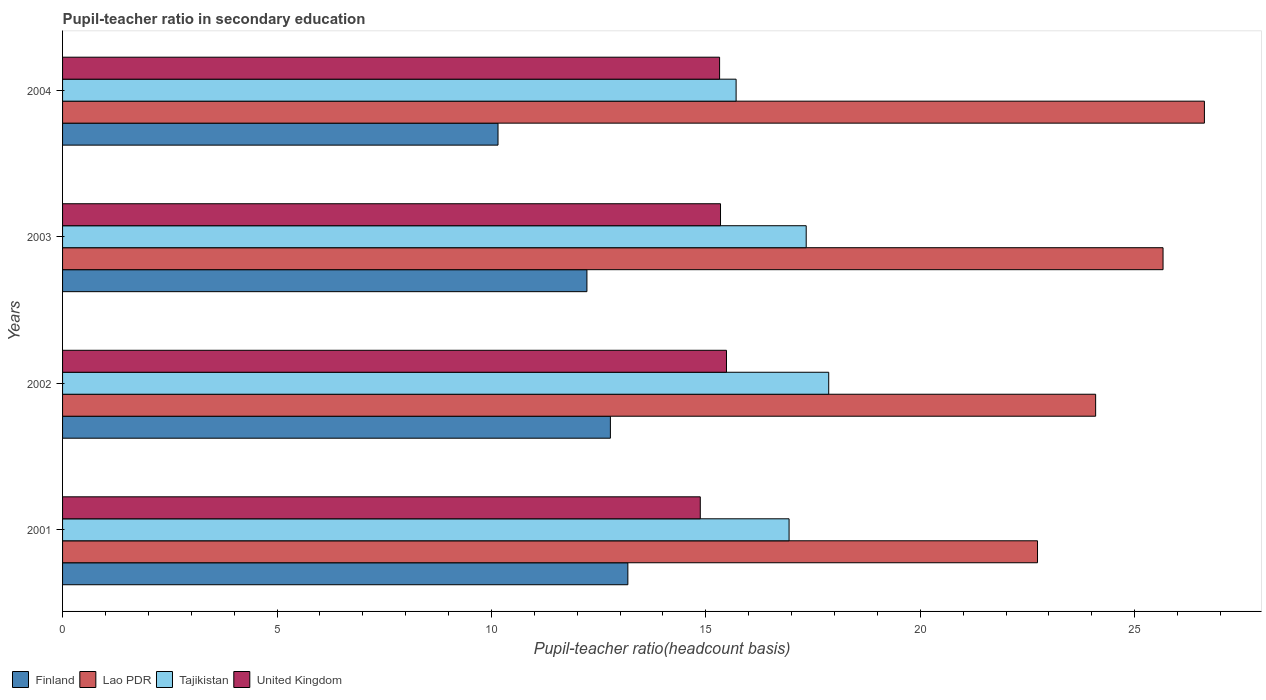Are the number of bars per tick equal to the number of legend labels?
Give a very brief answer. Yes. Are the number of bars on each tick of the Y-axis equal?
Your answer should be very brief. Yes. In how many cases, is the number of bars for a given year not equal to the number of legend labels?
Offer a terse response. 0. What is the pupil-teacher ratio in secondary education in Lao PDR in 2002?
Provide a short and direct response. 24.09. Across all years, what is the maximum pupil-teacher ratio in secondary education in Lao PDR?
Your response must be concise. 26.62. Across all years, what is the minimum pupil-teacher ratio in secondary education in Finland?
Offer a very short reply. 10.15. What is the total pupil-teacher ratio in secondary education in United Kingdom in the graph?
Ensure brevity in your answer.  61.01. What is the difference between the pupil-teacher ratio in secondary education in Tajikistan in 2001 and that in 2003?
Your response must be concise. -0.4. What is the difference between the pupil-teacher ratio in secondary education in Tajikistan in 2004 and the pupil-teacher ratio in secondary education in Finland in 2002?
Provide a short and direct response. 2.93. What is the average pupil-teacher ratio in secondary education in United Kingdom per year?
Provide a succinct answer. 15.25. In the year 2001, what is the difference between the pupil-teacher ratio in secondary education in Tajikistan and pupil-teacher ratio in secondary education in United Kingdom?
Your answer should be compact. 2.07. In how many years, is the pupil-teacher ratio in secondary education in United Kingdom greater than 23 ?
Keep it short and to the point. 0. What is the ratio of the pupil-teacher ratio in secondary education in Finland in 2001 to that in 2003?
Provide a short and direct response. 1.08. Is the pupil-teacher ratio in secondary education in Lao PDR in 2003 less than that in 2004?
Give a very brief answer. Yes. What is the difference between the highest and the second highest pupil-teacher ratio in secondary education in United Kingdom?
Offer a terse response. 0.14. What is the difference between the highest and the lowest pupil-teacher ratio in secondary education in Finland?
Your answer should be compact. 3.03. In how many years, is the pupil-teacher ratio in secondary education in United Kingdom greater than the average pupil-teacher ratio in secondary education in United Kingdom taken over all years?
Provide a short and direct response. 3. Is the sum of the pupil-teacher ratio in secondary education in Lao PDR in 2001 and 2003 greater than the maximum pupil-teacher ratio in secondary education in Tajikistan across all years?
Provide a succinct answer. Yes. Is it the case that in every year, the sum of the pupil-teacher ratio in secondary education in United Kingdom and pupil-teacher ratio in secondary education in Finland is greater than the sum of pupil-teacher ratio in secondary education in Tajikistan and pupil-teacher ratio in secondary education in Lao PDR?
Give a very brief answer. No. What does the 1st bar from the top in 2002 represents?
Make the answer very short. United Kingdom. What does the 1st bar from the bottom in 2004 represents?
Make the answer very short. Finland. Is it the case that in every year, the sum of the pupil-teacher ratio in secondary education in United Kingdom and pupil-teacher ratio in secondary education in Finland is greater than the pupil-teacher ratio in secondary education in Lao PDR?
Provide a short and direct response. No. How many bars are there?
Your answer should be very brief. 16. Are the values on the major ticks of X-axis written in scientific E-notation?
Offer a terse response. No. Does the graph contain grids?
Your answer should be compact. No. What is the title of the graph?
Make the answer very short. Pupil-teacher ratio in secondary education. What is the label or title of the X-axis?
Provide a succinct answer. Pupil-teacher ratio(headcount basis). What is the label or title of the Y-axis?
Give a very brief answer. Years. What is the Pupil-teacher ratio(headcount basis) of Finland in 2001?
Offer a very short reply. 13.18. What is the Pupil-teacher ratio(headcount basis) in Lao PDR in 2001?
Provide a succinct answer. 22.73. What is the Pupil-teacher ratio(headcount basis) in Tajikistan in 2001?
Provide a succinct answer. 16.94. What is the Pupil-teacher ratio(headcount basis) of United Kingdom in 2001?
Make the answer very short. 14.87. What is the Pupil-teacher ratio(headcount basis) in Finland in 2002?
Offer a very short reply. 12.77. What is the Pupil-teacher ratio(headcount basis) in Lao PDR in 2002?
Your answer should be compact. 24.09. What is the Pupil-teacher ratio(headcount basis) in Tajikistan in 2002?
Keep it short and to the point. 17.86. What is the Pupil-teacher ratio(headcount basis) in United Kingdom in 2002?
Ensure brevity in your answer.  15.48. What is the Pupil-teacher ratio(headcount basis) in Finland in 2003?
Keep it short and to the point. 12.23. What is the Pupil-teacher ratio(headcount basis) in Lao PDR in 2003?
Make the answer very short. 25.66. What is the Pupil-teacher ratio(headcount basis) of Tajikistan in 2003?
Offer a very short reply. 17.34. What is the Pupil-teacher ratio(headcount basis) in United Kingdom in 2003?
Your response must be concise. 15.34. What is the Pupil-teacher ratio(headcount basis) in Finland in 2004?
Keep it short and to the point. 10.15. What is the Pupil-teacher ratio(headcount basis) in Lao PDR in 2004?
Your answer should be compact. 26.62. What is the Pupil-teacher ratio(headcount basis) of Tajikistan in 2004?
Make the answer very short. 15.7. What is the Pupil-teacher ratio(headcount basis) of United Kingdom in 2004?
Offer a terse response. 15.32. Across all years, what is the maximum Pupil-teacher ratio(headcount basis) of Finland?
Ensure brevity in your answer.  13.18. Across all years, what is the maximum Pupil-teacher ratio(headcount basis) of Lao PDR?
Provide a short and direct response. 26.62. Across all years, what is the maximum Pupil-teacher ratio(headcount basis) of Tajikistan?
Your response must be concise. 17.86. Across all years, what is the maximum Pupil-teacher ratio(headcount basis) of United Kingdom?
Offer a very short reply. 15.48. Across all years, what is the minimum Pupil-teacher ratio(headcount basis) of Finland?
Provide a succinct answer. 10.15. Across all years, what is the minimum Pupil-teacher ratio(headcount basis) of Lao PDR?
Offer a terse response. 22.73. Across all years, what is the minimum Pupil-teacher ratio(headcount basis) of Tajikistan?
Provide a succinct answer. 15.7. Across all years, what is the minimum Pupil-teacher ratio(headcount basis) in United Kingdom?
Give a very brief answer. 14.87. What is the total Pupil-teacher ratio(headcount basis) in Finland in the graph?
Your answer should be compact. 48.33. What is the total Pupil-teacher ratio(headcount basis) of Lao PDR in the graph?
Your response must be concise. 99.1. What is the total Pupil-teacher ratio(headcount basis) in Tajikistan in the graph?
Give a very brief answer. 67.85. What is the total Pupil-teacher ratio(headcount basis) in United Kingdom in the graph?
Offer a very short reply. 61.01. What is the difference between the Pupil-teacher ratio(headcount basis) of Finland in 2001 and that in 2002?
Provide a succinct answer. 0.41. What is the difference between the Pupil-teacher ratio(headcount basis) of Lao PDR in 2001 and that in 2002?
Your answer should be compact. -1.36. What is the difference between the Pupil-teacher ratio(headcount basis) of Tajikistan in 2001 and that in 2002?
Provide a succinct answer. -0.92. What is the difference between the Pupil-teacher ratio(headcount basis) of United Kingdom in 2001 and that in 2002?
Keep it short and to the point. -0.61. What is the difference between the Pupil-teacher ratio(headcount basis) of Finland in 2001 and that in 2003?
Keep it short and to the point. 0.95. What is the difference between the Pupil-teacher ratio(headcount basis) in Lao PDR in 2001 and that in 2003?
Offer a terse response. -2.93. What is the difference between the Pupil-teacher ratio(headcount basis) of Tajikistan in 2001 and that in 2003?
Keep it short and to the point. -0.4. What is the difference between the Pupil-teacher ratio(headcount basis) in United Kingdom in 2001 and that in 2003?
Offer a terse response. -0.47. What is the difference between the Pupil-teacher ratio(headcount basis) of Finland in 2001 and that in 2004?
Give a very brief answer. 3.03. What is the difference between the Pupil-teacher ratio(headcount basis) of Lao PDR in 2001 and that in 2004?
Keep it short and to the point. -3.89. What is the difference between the Pupil-teacher ratio(headcount basis) in Tajikistan in 2001 and that in 2004?
Provide a short and direct response. 1.24. What is the difference between the Pupil-teacher ratio(headcount basis) in United Kingdom in 2001 and that in 2004?
Keep it short and to the point. -0.45. What is the difference between the Pupil-teacher ratio(headcount basis) of Finland in 2002 and that in 2003?
Provide a succinct answer. 0.55. What is the difference between the Pupil-teacher ratio(headcount basis) of Lao PDR in 2002 and that in 2003?
Keep it short and to the point. -1.57. What is the difference between the Pupil-teacher ratio(headcount basis) of Tajikistan in 2002 and that in 2003?
Offer a terse response. 0.53. What is the difference between the Pupil-teacher ratio(headcount basis) in United Kingdom in 2002 and that in 2003?
Provide a short and direct response. 0.14. What is the difference between the Pupil-teacher ratio(headcount basis) in Finland in 2002 and that in 2004?
Offer a very short reply. 2.62. What is the difference between the Pupil-teacher ratio(headcount basis) of Lao PDR in 2002 and that in 2004?
Your answer should be very brief. -2.54. What is the difference between the Pupil-teacher ratio(headcount basis) in Tajikistan in 2002 and that in 2004?
Keep it short and to the point. 2.16. What is the difference between the Pupil-teacher ratio(headcount basis) in United Kingdom in 2002 and that in 2004?
Provide a short and direct response. 0.16. What is the difference between the Pupil-teacher ratio(headcount basis) of Finland in 2003 and that in 2004?
Offer a terse response. 2.07. What is the difference between the Pupil-teacher ratio(headcount basis) of Lao PDR in 2003 and that in 2004?
Your answer should be compact. -0.96. What is the difference between the Pupil-teacher ratio(headcount basis) in Tajikistan in 2003 and that in 2004?
Provide a short and direct response. 1.63. What is the difference between the Pupil-teacher ratio(headcount basis) in United Kingdom in 2003 and that in 2004?
Keep it short and to the point. 0.02. What is the difference between the Pupil-teacher ratio(headcount basis) of Finland in 2001 and the Pupil-teacher ratio(headcount basis) of Lao PDR in 2002?
Ensure brevity in your answer.  -10.91. What is the difference between the Pupil-teacher ratio(headcount basis) of Finland in 2001 and the Pupil-teacher ratio(headcount basis) of Tajikistan in 2002?
Provide a succinct answer. -4.68. What is the difference between the Pupil-teacher ratio(headcount basis) of Finland in 2001 and the Pupil-teacher ratio(headcount basis) of United Kingdom in 2002?
Offer a terse response. -2.3. What is the difference between the Pupil-teacher ratio(headcount basis) in Lao PDR in 2001 and the Pupil-teacher ratio(headcount basis) in Tajikistan in 2002?
Keep it short and to the point. 4.87. What is the difference between the Pupil-teacher ratio(headcount basis) of Lao PDR in 2001 and the Pupil-teacher ratio(headcount basis) of United Kingdom in 2002?
Give a very brief answer. 7.25. What is the difference between the Pupil-teacher ratio(headcount basis) of Tajikistan in 2001 and the Pupil-teacher ratio(headcount basis) of United Kingdom in 2002?
Your answer should be compact. 1.46. What is the difference between the Pupil-teacher ratio(headcount basis) of Finland in 2001 and the Pupil-teacher ratio(headcount basis) of Lao PDR in 2003?
Make the answer very short. -12.48. What is the difference between the Pupil-teacher ratio(headcount basis) in Finland in 2001 and the Pupil-teacher ratio(headcount basis) in Tajikistan in 2003?
Provide a succinct answer. -4.16. What is the difference between the Pupil-teacher ratio(headcount basis) in Finland in 2001 and the Pupil-teacher ratio(headcount basis) in United Kingdom in 2003?
Make the answer very short. -2.16. What is the difference between the Pupil-teacher ratio(headcount basis) of Lao PDR in 2001 and the Pupil-teacher ratio(headcount basis) of Tajikistan in 2003?
Provide a short and direct response. 5.39. What is the difference between the Pupil-teacher ratio(headcount basis) of Lao PDR in 2001 and the Pupil-teacher ratio(headcount basis) of United Kingdom in 2003?
Your answer should be very brief. 7.39. What is the difference between the Pupil-teacher ratio(headcount basis) in Tajikistan in 2001 and the Pupil-teacher ratio(headcount basis) in United Kingdom in 2003?
Keep it short and to the point. 1.6. What is the difference between the Pupil-teacher ratio(headcount basis) in Finland in 2001 and the Pupil-teacher ratio(headcount basis) in Lao PDR in 2004?
Ensure brevity in your answer.  -13.44. What is the difference between the Pupil-teacher ratio(headcount basis) of Finland in 2001 and the Pupil-teacher ratio(headcount basis) of Tajikistan in 2004?
Offer a very short reply. -2.52. What is the difference between the Pupil-teacher ratio(headcount basis) of Finland in 2001 and the Pupil-teacher ratio(headcount basis) of United Kingdom in 2004?
Provide a short and direct response. -2.14. What is the difference between the Pupil-teacher ratio(headcount basis) of Lao PDR in 2001 and the Pupil-teacher ratio(headcount basis) of Tajikistan in 2004?
Ensure brevity in your answer.  7.03. What is the difference between the Pupil-teacher ratio(headcount basis) of Lao PDR in 2001 and the Pupil-teacher ratio(headcount basis) of United Kingdom in 2004?
Provide a succinct answer. 7.41. What is the difference between the Pupil-teacher ratio(headcount basis) in Tajikistan in 2001 and the Pupil-teacher ratio(headcount basis) in United Kingdom in 2004?
Your answer should be very brief. 1.62. What is the difference between the Pupil-teacher ratio(headcount basis) in Finland in 2002 and the Pupil-teacher ratio(headcount basis) in Lao PDR in 2003?
Give a very brief answer. -12.89. What is the difference between the Pupil-teacher ratio(headcount basis) of Finland in 2002 and the Pupil-teacher ratio(headcount basis) of Tajikistan in 2003?
Offer a very short reply. -4.57. What is the difference between the Pupil-teacher ratio(headcount basis) in Finland in 2002 and the Pupil-teacher ratio(headcount basis) in United Kingdom in 2003?
Provide a succinct answer. -2.57. What is the difference between the Pupil-teacher ratio(headcount basis) of Lao PDR in 2002 and the Pupil-teacher ratio(headcount basis) of Tajikistan in 2003?
Provide a short and direct response. 6.75. What is the difference between the Pupil-teacher ratio(headcount basis) of Lao PDR in 2002 and the Pupil-teacher ratio(headcount basis) of United Kingdom in 2003?
Provide a short and direct response. 8.75. What is the difference between the Pupil-teacher ratio(headcount basis) in Tajikistan in 2002 and the Pupil-teacher ratio(headcount basis) in United Kingdom in 2003?
Give a very brief answer. 2.52. What is the difference between the Pupil-teacher ratio(headcount basis) in Finland in 2002 and the Pupil-teacher ratio(headcount basis) in Lao PDR in 2004?
Your answer should be compact. -13.85. What is the difference between the Pupil-teacher ratio(headcount basis) of Finland in 2002 and the Pupil-teacher ratio(headcount basis) of Tajikistan in 2004?
Offer a very short reply. -2.93. What is the difference between the Pupil-teacher ratio(headcount basis) in Finland in 2002 and the Pupil-teacher ratio(headcount basis) in United Kingdom in 2004?
Make the answer very short. -2.55. What is the difference between the Pupil-teacher ratio(headcount basis) in Lao PDR in 2002 and the Pupil-teacher ratio(headcount basis) in Tajikistan in 2004?
Your answer should be compact. 8.38. What is the difference between the Pupil-teacher ratio(headcount basis) in Lao PDR in 2002 and the Pupil-teacher ratio(headcount basis) in United Kingdom in 2004?
Ensure brevity in your answer.  8.77. What is the difference between the Pupil-teacher ratio(headcount basis) of Tajikistan in 2002 and the Pupil-teacher ratio(headcount basis) of United Kingdom in 2004?
Your answer should be very brief. 2.54. What is the difference between the Pupil-teacher ratio(headcount basis) in Finland in 2003 and the Pupil-teacher ratio(headcount basis) in Lao PDR in 2004?
Offer a terse response. -14.4. What is the difference between the Pupil-teacher ratio(headcount basis) in Finland in 2003 and the Pupil-teacher ratio(headcount basis) in Tajikistan in 2004?
Provide a succinct answer. -3.48. What is the difference between the Pupil-teacher ratio(headcount basis) of Finland in 2003 and the Pupil-teacher ratio(headcount basis) of United Kingdom in 2004?
Give a very brief answer. -3.09. What is the difference between the Pupil-teacher ratio(headcount basis) of Lao PDR in 2003 and the Pupil-teacher ratio(headcount basis) of Tajikistan in 2004?
Provide a short and direct response. 9.96. What is the difference between the Pupil-teacher ratio(headcount basis) in Lao PDR in 2003 and the Pupil-teacher ratio(headcount basis) in United Kingdom in 2004?
Offer a very short reply. 10.34. What is the difference between the Pupil-teacher ratio(headcount basis) of Tajikistan in 2003 and the Pupil-teacher ratio(headcount basis) of United Kingdom in 2004?
Give a very brief answer. 2.02. What is the average Pupil-teacher ratio(headcount basis) in Finland per year?
Keep it short and to the point. 12.08. What is the average Pupil-teacher ratio(headcount basis) in Lao PDR per year?
Offer a terse response. 24.78. What is the average Pupil-teacher ratio(headcount basis) of Tajikistan per year?
Your response must be concise. 16.96. What is the average Pupil-teacher ratio(headcount basis) in United Kingdom per year?
Provide a succinct answer. 15.25. In the year 2001, what is the difference between the Pupil-teacher ratio(headcount basis) in Finland and Pupil-teacher ratio(headcount basis) in Lao PDR?
Give a very brief answer. -9.55. In the year 2001, what is the difference between the Pupil-teacher ratio(headcount basis) of Finland and Pupil-teacher ratio(headcount basis) of Tajikistan?
Ensure brevity in your answer.  -3.76. In the year 2001, what is the difference between the Pupil-teacher ratio(headcount basis) of Finland and Pupil-teacher ratio(headcount basis) of United Kingdom?
Your answer should be very brief. -1.69. In the year 2001, what is the difference between the Pupil-teacher ratio(headcount basis) in Lao PDR and Pupil-teacher ratio(headcount basis) in Tajikistan?
Offer a very short reply. 5.79. In the year 2001, what is the difference between the Pupil-teacher ratio(headcount basis) in Lao PDR and Pupil-teacher ratio(headcount basis) in United Kingdom?
Offer a very short reply. 7.86. In the year 2001, what is the difference between the Pupil-teacher ratio(headcount basis) in Tajikistan and Pupil-teacher ratio(headcount basis) in United Kingdom?
Keep it short and to the point. 2.07. In the year 2002, what is the difference between the Pupil-teacher ratio(headcount basis) of Finland and Pupil-teacher ratio(headcount basis) of Lao PDR?
Offer a very short reply. -11.31. In the year 2002, what is the difference between the Pupil-teacher ratio(headcount basis) in Finland and Pupil-teacher ratio(headcount basis) in Tajikistan?
Offer a terse response. -5.09. In the year 2002, what is the difference between the Pupil-teacher ratio(headcount basis) of Finland and Pupil-teacher ratio(headcount basis) of United Kingdom?
Provide a short and direct response. -2.71. In the year 2002, what is the difference between the Pupil-teacher ratio(headcount basis) in Lao PDR and Pupil-teacher ratio(headcount basis) in Tajikistan?
Your response must be concise. 6.22. In the year 2002, what is the difference between the Pupil-teacher ratio(headcount basis) of Lao PDR and Pupil-teacher ratio(headcount basis) of United Kingdom?
Offer a terse response. 8.61. In the year 2002, what is the difference between the Pupil-teacher ratio(headcount basis) in Tajikistan and Pupil-teacher ratio(headcount basis) in United Kingdom?
Your answer should be very brief. 2.38. In the year 2003, what is the difference between the Pupil-teacher ratio(headcount basis) in Finland and Pupil-teacher ratio(headcount basis) in Lao PDR?
Offer a terse response. -13.43. In the year 2003, what is the difference between the Pupil-teacher ratio(headcount basis) of Finland and Pupil-teacher ratio(headcount basis) of Tajikistan?
Your answer should be very brief. -5.11. In the year 2003, what is the difference between the Pupil-teacher ratio(headcount basis) in Finland and Pupil-teacher ratio(headcount basis) in United Kingdom?
Provide a succinct answer. -3.12. In the year 2003, what is the difference between the Pupil-teacher ratio(headcount basis) in Lao PDR and Pupil-teacher ratio(headcount basis) in Tajikistan?
Provide a succinct answer. 8.32. In the year 2003, what is the difference between the Pupil-teacher ratio(headcount basis) of Lao PDR and Pupil-teacher ratio(headcount basis) of United Kingdom?
Offer a terse response. 10.32. In the year 2003, what is the difference between the Pupil-teacher ratio(headcount basis) in Tajikistan and Pupil-teacher ratio(headcount basis) in United Kingdom?
Provide a short and direct response. 2. In the year 2004, what is the difference between the Pupil-teacher ratio(headcount basis) of Finland and Pupil-teacher ratio(headcount basis) of Lao PDR?
Ensure brevity in your answer.  -16.47. In the year 2004, what is the difference between the Pupil-teacher ratio(headcount basis) in Finland and Pupil-teacher ratio(headcount basis) in Tajikistan?
Make the answer very short. -5.55. In the year 2004, what is the difference between the Pupil-teacher ratio(headcount basis) in Finland and Pupil-teacher ratio(headcount basis) in United Kingdom?
Your response must be concise. -5.17. In the year 2004, what is the difference between the Pupil-teacher ratio(headcount basis) of Lao PDR and Pupil-teacher ratio(headcount basis) of Tajikistan?
Your answer should be very brief. 10.92. In the year 2004, what is the difference between the Pupil-teacher ratio(headcount basis) of Lao PDR and Pupil-teacher ratio(headcount basis) of United Kingdom?
Your answer should be very brief. 11.3. In the year 2004, what is the difference between the Pupil-teacher ratio(headcount basis) of Tajikistan and Pupil-teacher ratio(headcount basis) of United Kingdom?
Offer a very short reply. 0.38. What is the ratio of the Pupil-teacher ratio(headcount basis) of Finland in 2001 to that in 2002?
Provide a short and direct response. 1.03. What is the ratio of the Pupil-teacher ratio(headcount basis) in Lao PDR in 2001 to that in 2002?
Your answer should be very brief. 0.94. What is the ratio of the Pupil-teacher ratio(headcount basis) of Tajikistan in 2001 to that in 2002?
Offer a terse response. 0.95. What is the ratio of the Pupil-teacher ratio(headcount basis) of United Kingdom in 2001 to that in 2002?
Keep it short and to the point. 0.96. What is the ratio of the Pupil-teacher ratio(headcount basis) of Finland in 2001 to that in 2003?
Provide a succinct answer. 1.08. What is the ratio of the Pupil-teacher ratio(headcount basis) of Lao PDR in 2001 to that in 2003?
Provide a short and direct response. 0.89. What is the ratio of the Pupil-teacher ratio(headcount basis) in Tajikistan in 2001 to that in 2003?
Offer a terse response. 0.98. What is the ratio of the Pupil-teacher ratio(headcount basis) in United Kingdom in 2001 to that in 2003?
Your answer should be compact. 0.97. What is the ratio of the Pupil-teacher ratio(headcount basis) of Finland in 2001 to that in 2004?
Offer a terse response. 1.3. What is the ratio of the Pupil-teacher ratio(headcount basis) in Lao PDR in 2001 to that in 2004?
Make the answer very short. 0.85. What is the ratio of the Pupil-teacher ratio(headcount basis) in Tajikistan in 2001 to that in 2004?
Provide a succinct answer. 1.08. What is the ratio of the Pupil-teacher ratio(headcount basis) in United Kingdom in 2001 to that in 2004?
Give a very brief answer. 0.97. What is the ratio of the Pupil-teacher ratio(headcount basis) in Finland in 2002 to that in 2003?
Your response must be concise. 1.04. What is the ratio of the Pupil-teacher ratio(headcount basis) in Lao PDR in 2002 to that in 2003?
Your answer should be compact. 0.94. What is the ratio of the Pupil-teacher ratio(headcount basis) in Tajikistan in 2002 to that in 2003?
Your answer should be compact. 1.03. What is the ratio of the Pupil-teacher ratio(headcount basis) of United Kingdom in 2002 to that in 2003?
Make the answer very short. 1.01. What is the ratio of the Pupil-teacher ratio(headcount basis) of Finland in 2002 to that in 2004?
Provide a short and direct response. 1.26. What is the ratio of the Pupil-teacher ratio(headcount basis) in Lao PDR in 2002 to that in 2004?
Your answer should be very brief. 0.9. What is the ratio of the Pupil-teacher ratio(headcount basis) of Tajikistan in 2002 to that in 2004?
Provide a succinct answer. 1.14. What is the ratio of the Pupil-teacher ratio(headcount basis) in United Kingdom in 2002 to that in 2004?
Provide a short and direct response. 1.01. What is the ratio of the Pupil-teacher ratio(headcount basis) of Finland in 2003 to that in 2004?
Your response must be concise. 1.2. What is the ratio of the Pupil-teacher ratio(headcount basis) of Lao PDR in 2003 to that in 2004?
Keep it short and to the point. 0.96. What is the ratio of the Pupil-teacher ratio(headcount basis) in Tajikistan in 2003 to that in 2004?
Keep it short and to the point. 1.1. What is the difference between the highest and the second highest Pupil-teacher ratio(headcount basis) in Finland?
Offer a terse response. 0.41. What is the difference between the highest and the second highest Pupil-teacher ratio(headcount basis) of Lao PDR?
Give a very brief answer. 0.96. What is the difference between the highest and the second highest Pupil-teacher ratio(headcount basis) in Tajikistan?
Keep it short and to the point. 0.53. What is the difference between the highest and the second highest Pupil-teacher ratio(headcount basis) of United Kingdom?
Ensure brevity in your answer.  0.14. What is the difference between the highest and the lowest Pupil-teacher ratio(headcount basis) in Finland?
Provide a succinct answer. 3.03. What is the difference between the highest and the lowest Pupil-teacher ratio(headcount basis) in Lao PDR?
Your answer should be compact. 3.89. What is the difference between the highest and the lowest Pupil-teacher ratio(headcount basis) of Tajikistan?
Provide a short and direct response. 2.16. What is the difference between the highest and the lowest Pupil-teacher ratio(headcount basis) of United Kingdom?
Your response must be concise. 0.61. 